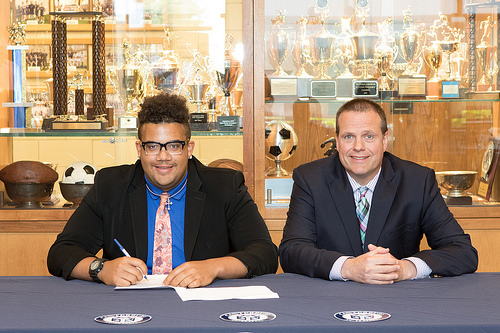<image>
Is the man behind the ball? No. The man is not behind the ball. From this viewpoint, the man appears to be positioned elsewhere in the scene. Is the ball to the right of the man? No. The ball is not to the right of the man. The horizontal positioning shows a different relationship. 